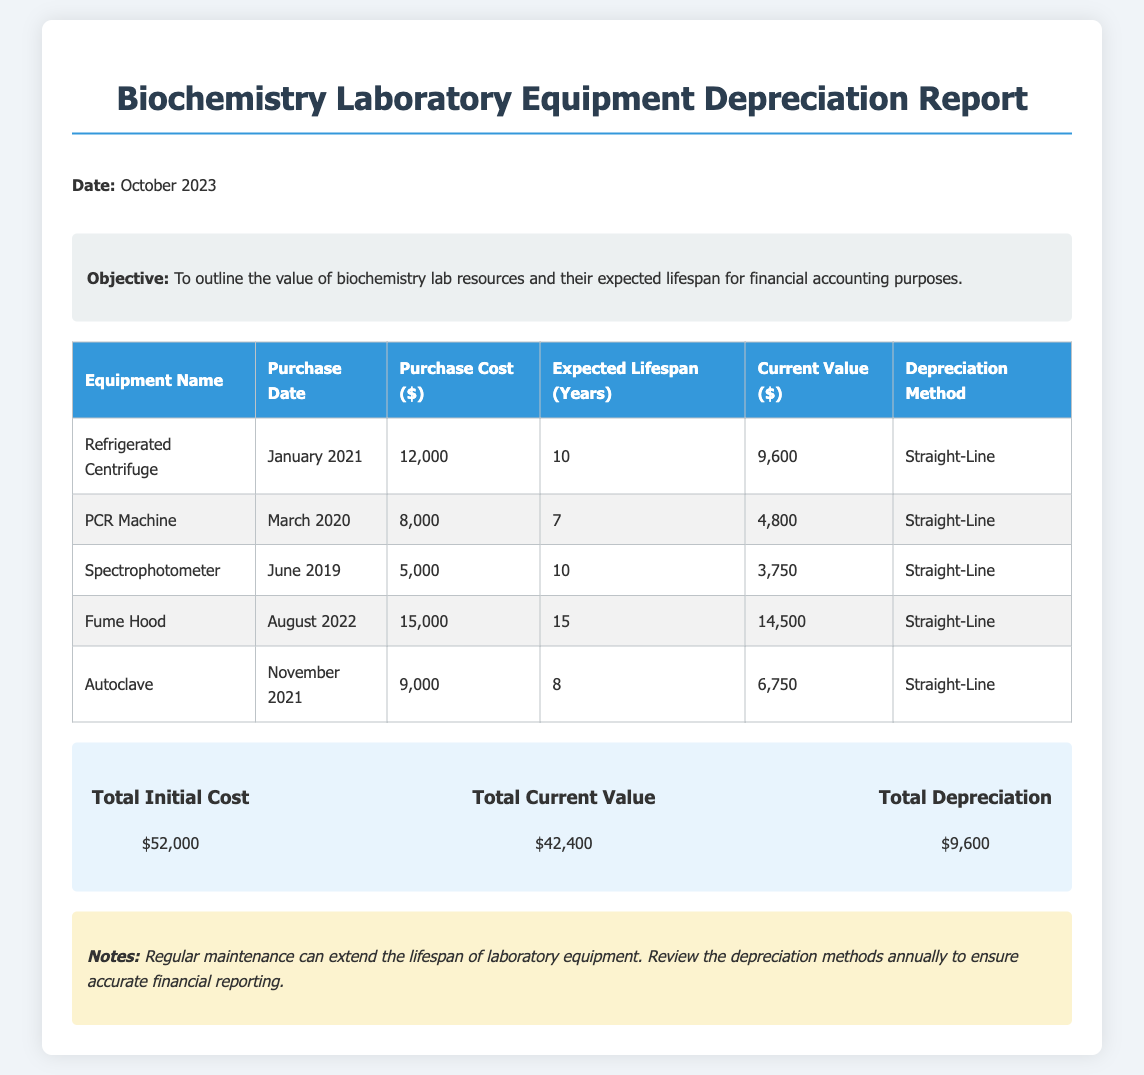What is the purchase cost of the Refrigerated Centrifuge? The purchase cost is given in the table under the respective equipment, which is $12,000.
Answer: $12,000 What is the expected lifespan of the Autoclave? The expected lifespan is noted in the table specifically for the Autoclave, which is 8 years.
Answer: 8 years What is the current value of the Spectrophotometer? The current value can be found in the table for the Spectrophotometer, which is $3,750.
Answer: $3,750 How much total depreciation is indicated in the report? The total depreciation is summarized in the report, amounting to $9,600.
Answer: $9,600 What is the total initial cost of all equipment listed? The total initial cost is provided in the summary section of the document as $52,000.
Answer: $52,000 What depreciation method is used for all the equipment? The depreciation method for all items listed is stated in the table, which is Straight-Line.
Answer: Straight-Line Which piece of equipment has the highest current value? The current values can be compared, and the Fume Hood stands out with the highest current value of $14,500.
Answer: Fume Hood What is the purchase date of the PCR Machine? The purchase date is provided in the equipment table, specifically stating March 2020.
Answer: March 2020 What is the objective of this report? The objective is outlined at the beginning of the document, indicating to outline the value of lab resources for financial purposes.
Answer: To outline the value of biochemistry lab resources and their expected lifespan for financial accounting purposes 